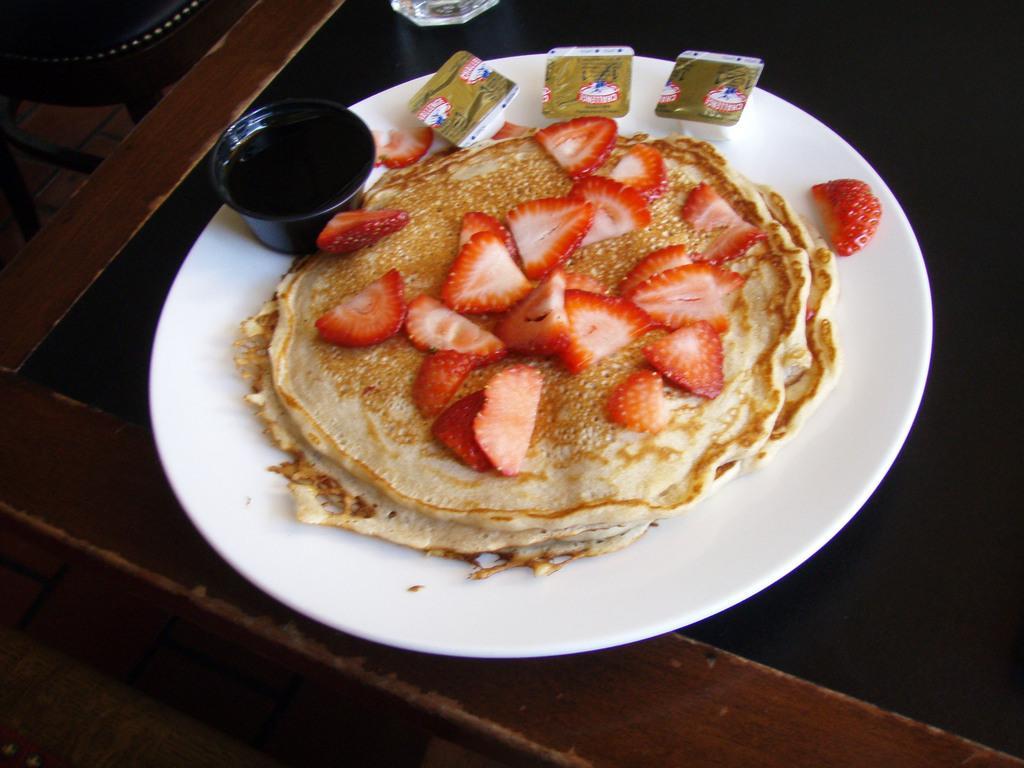Can you describe this image briefly? Here I can see a table on which a white color plate is placed. On the plate I can see some food item, strawberry slices and a black color bowl which consists of food item in it. 